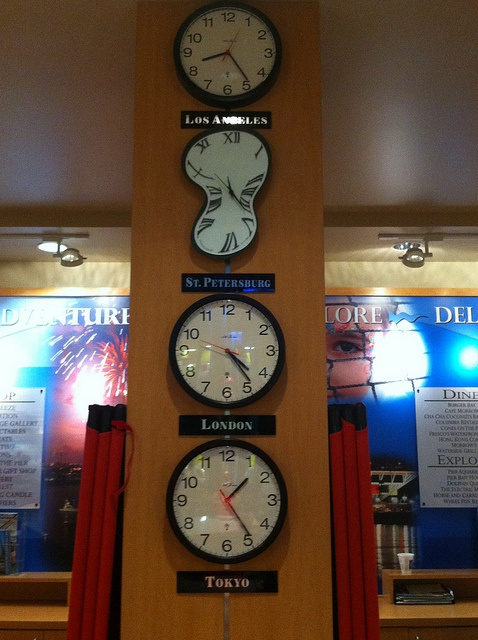Describe the objects in this image and their specific colors. I can see clock in maroon, gray, and black tones, clock in maroon, gray, black, and darkgray tones, clock in maroon, gray, and black tones, clock in maroon, gray, and black tones, and book in maroon, black, and gray tones in this image. 